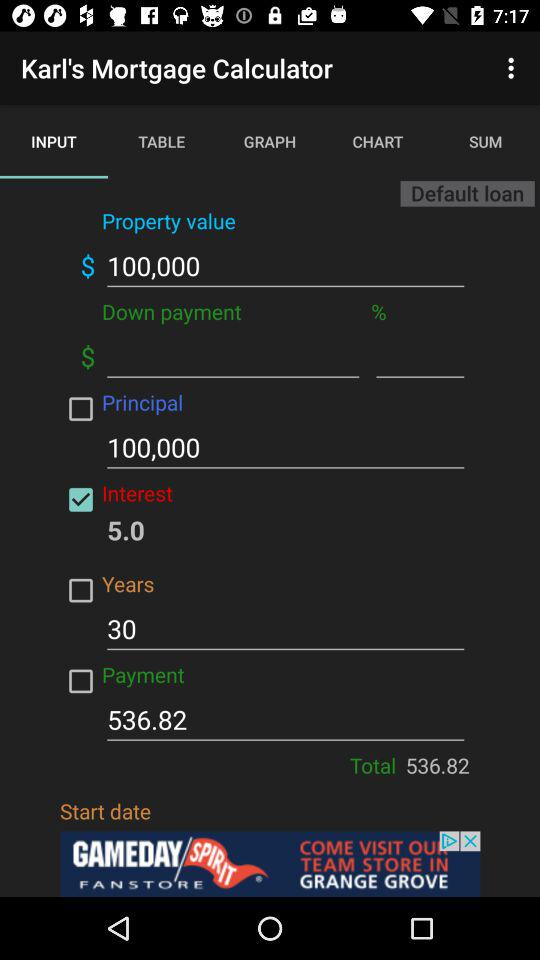What is the total payment? The total payment is 536.82. 